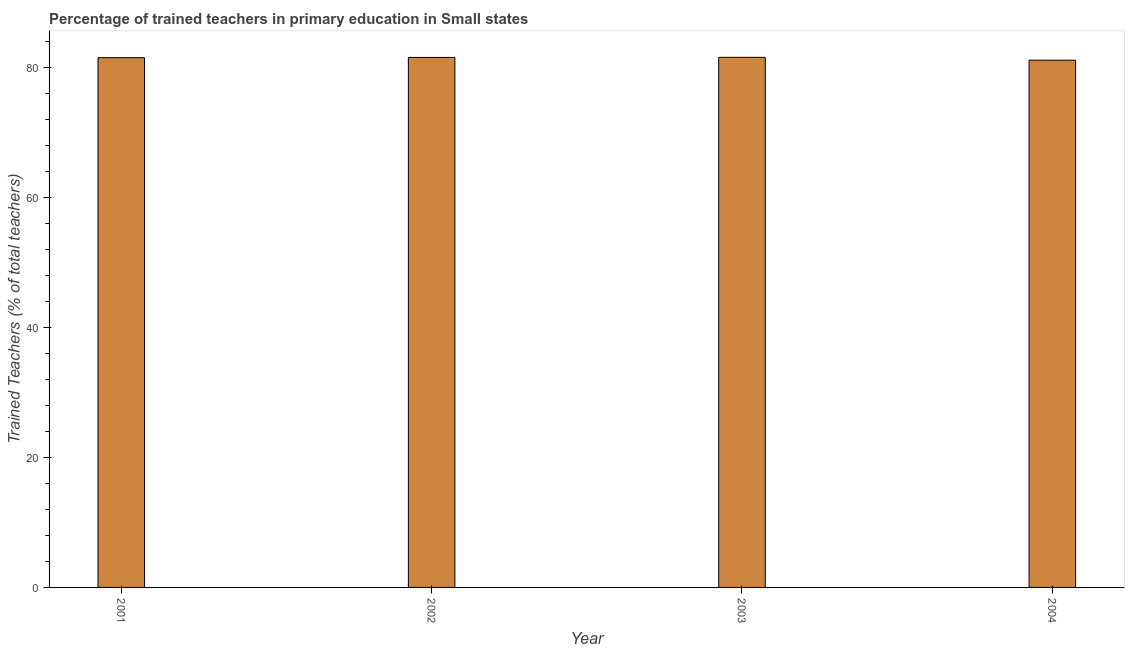Does the graph contain grids?
Offer a terse response. No. What is the title of the graph?
Your response must be concise. Percentage of trained teachers in primary education in Small states. What is the label or title of the X-axis?
Provide a short and direct response. Year. What is the label or title of the Y-axis?
Your answer should be compact. Trained Teachers (% of total teachers). What is the percentage of trained teachers in 2001?
Provide a succinct answer. 81.51. Across all years, what is the maximum percentage of trained teachers?
Your answer should be compact. 81.57. Across all years, what is the minimum percentage of trained teachers?
Offer a very short reply. 81.13. In which year was the percentage of trained teachers maximum?
Your answer should be compact. 2003. What is the sum of the percentage of trained teachers?
Provide a short and direct response. 325.75. What is the difference between the percentage of trained teachers in 2002 and 2004?
Your answer should be compact. 0.42. What is the average percentage of trained teachers per year?
Ensure brevity in your answer.  81.44. What is the median percentage of trained teachers?
Offer a terse response. 81.53. In how many years, is the percentage of trained teachers greater than 24 %?
Provide a short and direct response. 4. Do a majority of the years between 2003 and 2001 (inclusive) have percentage of trained teachers greater than 60 %?
Ensure brevity in your answer.  Yes. What is the ratio of the percentage of trained teachers in 2001 to that in 2004?
Your answer should be compact. 1. Is the percentage of trained teachers in 2001 less than that in 2004?
Your response must be concise. No. What is the difference between the highest and the second highest percentage of trained teachers?
Provide a short and direct response. 0.01. Is the sum of the percentage of trained teachers in 2001 and 2003 greater than the maximum percentage of trained teachers across all years?
Your response must be concise. Yes. What is the difference between the highest and the lowest percentage of trained teachers?
Offer a very short reply. 0.44. In how many years, is the percentage of trained teachers greater than the average percentage of trained teachers taken over all years?
Offer a very short reply. 3. How many bars are there?
Provide a short and direct response. 4. What is the difference between two consecutive major ticks on the Y-axis?
Your response must be concise. 20. Are the values on the major ticks of Y-axis written in scientific E-notation?
Give a very brief answer. No. What is the Trained Teachers (% of total teachers) of 2001?
Your answer should be very brief. 81.51. What is the Trained Teachers (% of total teachers) of 2002?
Offer a terse response. 81.55. What is the Trained Teachers (% of total teachers) of 2003?
Offer a terse response. 81.57. What is the Trained Teachers (% of total teachers) in 2004?
Ensure brevity in your answer.  81.13. What is the difference between the Trained Teachers (% of total teachers) in 2001 and 2002?
Ensure brevity in your answer.  -0.04. What is the difference between the Trained Teachers (% of total teachers) in 2001 and 2003?
Provide a succinct answer. -0.06. What is the difference between the Trained Teachers (% of total teachers) in 2001 and 2004?
Your answer should be compact. 0.38. What is the difference between the Trained Teachers (% of total teachers) in 2002 and 2003?
Give a very brief answer. -0.02. What is the difference between the Trained Teachers (% of total teachers) in 2002 and 2004?
Provide a short and direct response. 0.42. What is the difference between the Trained Teachers (% of total teachers) in 2003 and 2004?
Your answer should be compact. 0.44. What is the ratio of the Trained Teachers (% of total teachers) in 2001 to that in 2002?
Your answer should be compact. 1. What is the ratio of the Trained Teachers (% of total teachers) in 2001 to that in 2003?
Offer a terse response. 1. What is the ratio of the Trained Teachers (% of total teachers) in 2001 to that in 2004?
Offer a terse response. 1. What is the ratio of the Trained Teachers (% of total teachers) in 2002 to that in 2003?
Provide a succinct answer. 1. What is the ratio of the Trained Teachers (% of total teachers) in 2002 to that in 2004?
Your answer should be very brief. 1. 